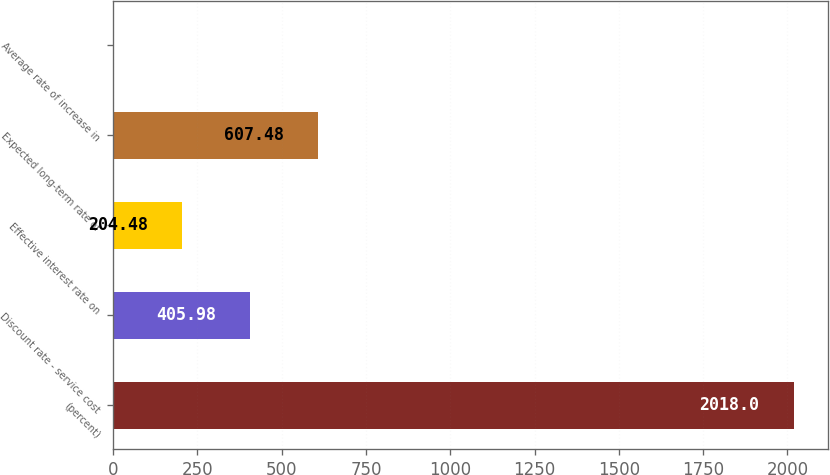Convert chart. <chart><loc_0><loc_0><loc_500><loc_500><bar_chart><fcel>(percent)<fcel>Discount rate - service cost<fcel>Effective interest rate on<fcel>Expected long-term rate of<fcel>Average rate of increase in<nl><fcel>2018<fcel>405.98<fcel>204.48<fcel>607.48<fcel>2.98<nl></chart> 